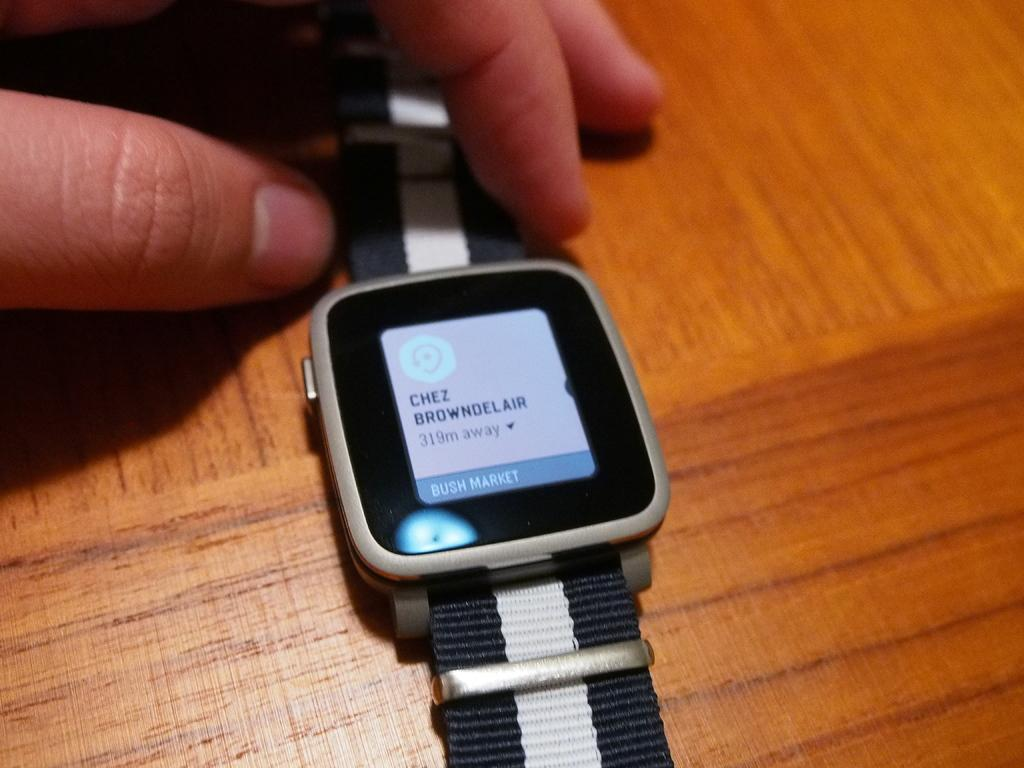<image>
Share a concise interpretation of the image provided. the word chez that is on the watch 